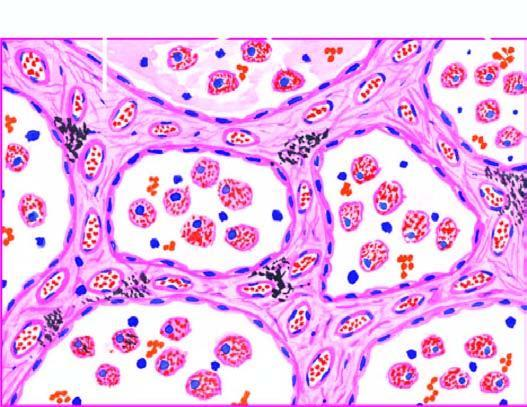what contain heart failure cells alveolar macrophages containing haemosiderin pigment?
Answer the question using a single word or phrase. The alveolar lumina 